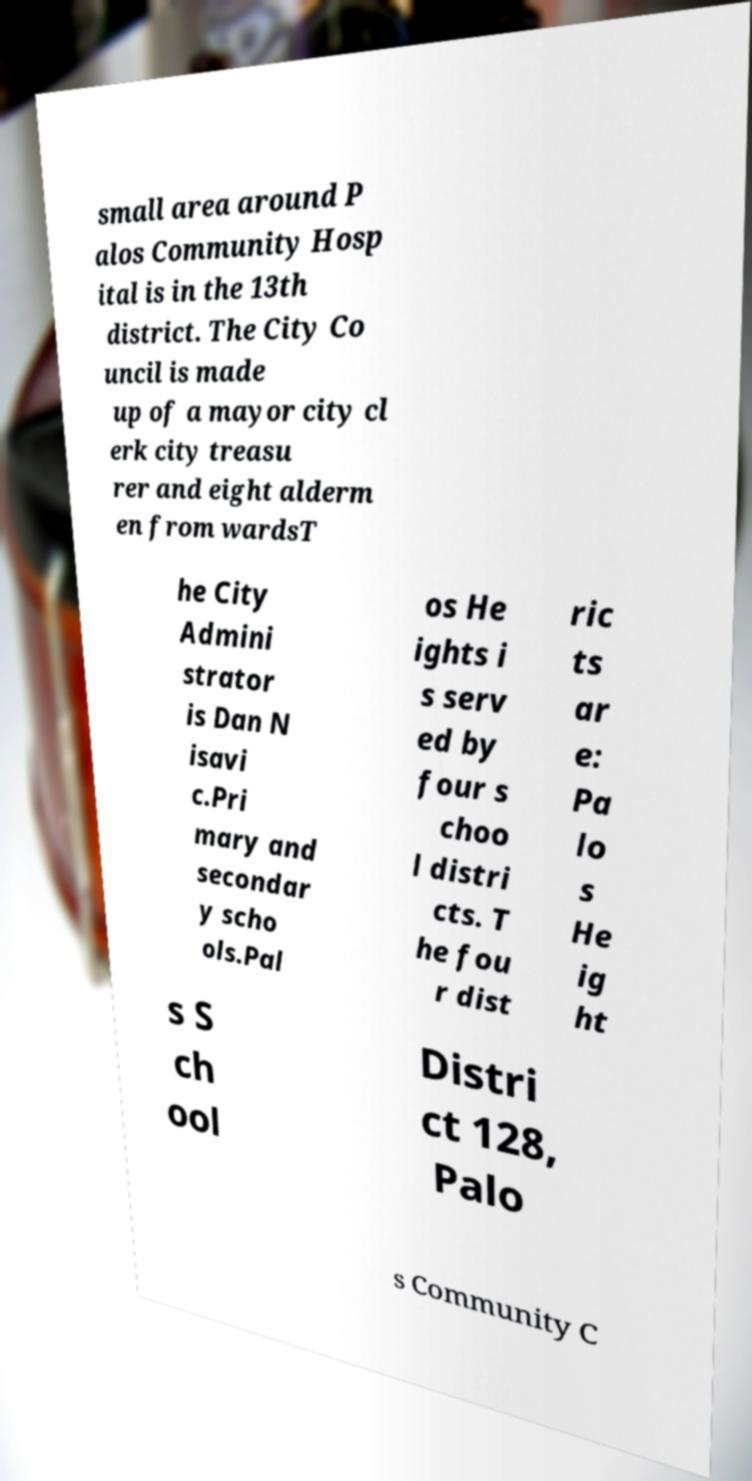For documentation purposes, I need the text within this image transcribed. Could you provide that? small area around P alos Community Hosp ital is in the 13th district. The City Co uncil is made up of a mayor city cl erk city treasu rer and eight alderm en from wardsT he City Admini strator is Dan N isavi c.Pri mary and secondar y scho ols.Pal os He ights i s serv ed by four s choo l distri cts. T he fou r dist ric ts ar e: Pa lo s He ig ht s S ch ool Distri ct 128, Palo s Community C 